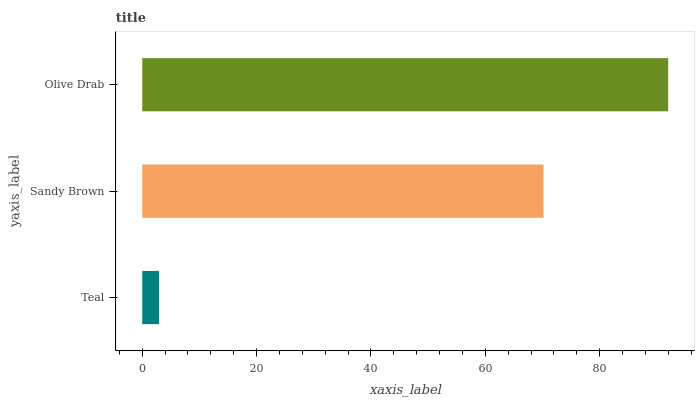Is Teal the minimum?
Answer yes or no. Yes. Is Olive Drab the maximum?
Answer yes or no. Yes. Is Sandy Brown the minimum?
Answer yes or no. No. Is Sandy Brown the maximum?
Answer yes or no. No. Is Sandy Brown greater than Teal?
Answer yes or no. Yes. Is Teal less than Sandy Brown?
Answer yes or no. Yes. Is Teal greater than Sandy Brown?
Answer yes or no. No. Is Sandy Brown less than Teal?
Answer yes or no. No. Is Sandy Brown the high median?
Answer yes or no. Yes. Is Sandy Brown the low median?
Answer yes or no. Yes. Is Teal the high median?
Answer yes or no. No. Is Olive Drab the low median?
Answer yes or no. No. 